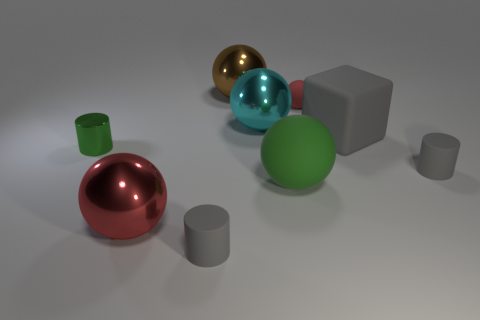There is a large cyan shiny thing; what number of balls are behind it?
Give a very brief answer. 2. There is a tiny thing that is made of the same material as the large red sphere; what color is it?
Ensure brevity in your answer.  Green. What number of shiny objects are either gray things or tiny red balls?
Give a very brief answer. 0. Do the big green thing and the cyan sphere have the same material?
Offer a terse response. No. What shape is the shiny thing that is behind the large cyan metallic ball?
Provide a short and direct response. Sphere. There is a rubber ball that is behind the cyan shiny object; are there any tiny rubber objects behind it?
Offer a terse response. No. Is there a metal cylinder of the same size as the cyan metal sphere?
Give a very brief answer. No. Do the big matte object that is to the right of the small ball and the tiny metallic thing have the same color?
Make the answer very short. No. What is the size of the block?
Give a very brief answer. Large. How big is the gray rubber thing left of the red object that is behind the small shiny cylinder?
Keep it short and to the point. Small. 